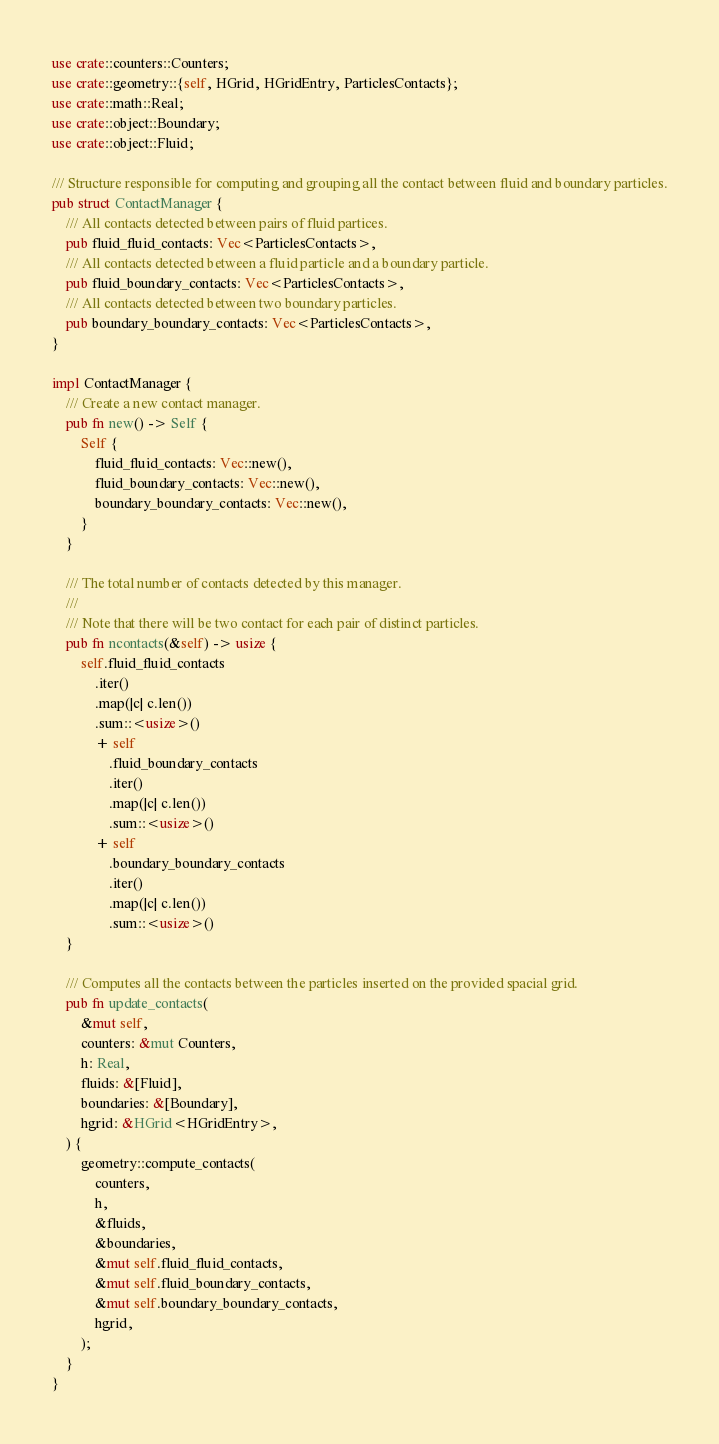Convert code to text. <code><loc_0><loc_0><loc_500><loc_500><_Rust_>use crate::counters::Counters;
use crate::geometry::{self, HGrid, HGridEntry, ParticlesContacts};
use crate::math::Real;
use crate::object::Boundary;
use crate::object::Fluid;

/// Structure responsible for computing and grouping all the contact between fluid and boundary particles.
pub struct ContactManager {
    /// All contacts detected between pairs of fluid partices.
    pub fluid_fluid_contacts: Vec<ParticlesContacts>,
    /// All contacts detected between a fluid particle and a boundary particle.
    pub fluid_boundary_contacts: Vec<ParticlesContacts>,
    /// All contacts detected between two boundary particles.
    pub boundary_boundary_contacts: Vec<ParticlesContacts>,
}

impl ContactManager {
    /// Create a new contact manager.
    pub fn new() -> Self {
        Self {
            fluid_fluid_contacts: Vec::new(),
            fluid_boundary_contacts: Vec::new(),
            boundary_boundary_contacts: Vec::new(),
        }
    }

    /// The total number of contacts detected by this manager.
    ///
    /// Note that there will be two contact for each pair of distinct particles.
    pub fn ncontacts(&self) -> usize {
        self.fluid_fluid_contacts
            .iter()
            .map(|c| c.len())
            .sum::<usize>()
            + self
                .fluid_boundary_contacts
                .iter()
                .map(|c| c.len())
                .sum::<usize>()
            + self
                .boundary_boundary_contacts
                .iter()
                .map(|c| c.len())
                .sum::<usize>()
    }

    /// Computes all the contacts between the particles inserted on the provided spacial grid.
    pub fn update_contacts(
        &mut self,
        counters: &mut Counters,
        h: Real,
        fluids: &[Fluid],
        boundaries: &[Boundary],
        hgrid: &HGrid<HGridEntry>,
    ) {
        geometry::compute_contacts(
            counters,
            h,
            &fluids,
            &boundaries,
            &mut self.fluid_fluid_contacts,
            &mut self.fluid_boundary_contacts,
            &mut self.boundary_boundary_contacts,
            hgrid,
        );
    }
}
</code> 